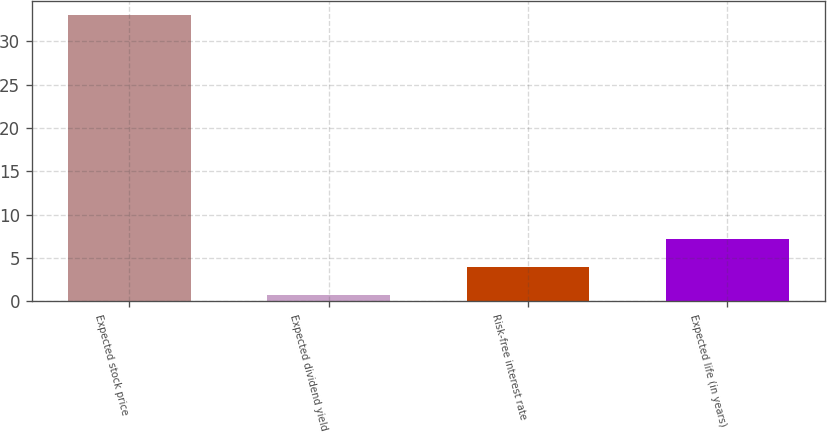<chart> <loc_0><loc_0><loc_500><loc_500><bar_chart><fcel>Expected stock price<fcel>Expected dividend yield<fcel>Risk-free interest rate<fcel>Expected life (in years)<nl><fcel>33<fcel>0.7<fcel>3.93<fcel>7.16<nl></chart> 